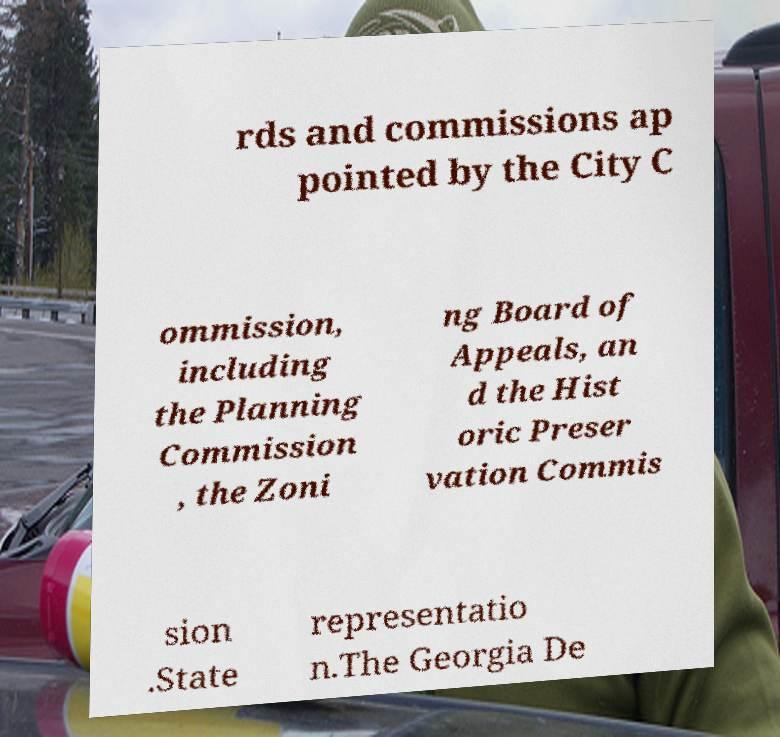Can you read and provide the text displayed in the image?This photo seems to have some interesting text. Can you extract and type it out for me? rds and commissions ap pointed by the City C ommission, including the Planning Commission , the Zoni ng Board of Appeals, an d the Hist oric Preser vation Commis sion .State representatio n.The Georgia De 